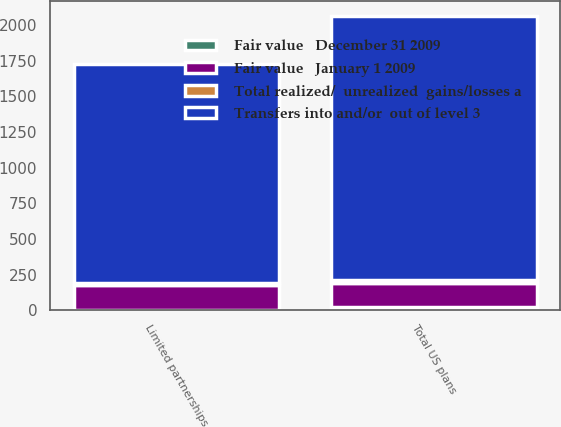Convert chart to OTSL. <chart><loc_0><loc_0><loc_500><loc_500><stacked_bar_chart><ecel><fcel>Limited partnerships<fcel>Total US plans<nl><fcel>Transfers into and/or  out of level 3<fcel>1537<fcel>1852<nl><fcel>Fair value   December 31 2009<fcel>4<fcel>23<nl><fcel>Fair value   January 1 2009<fcel>171<fcel>171<nl><fcel>Total realized/  unrealized  gains/losses a<fcel>15<fcel>15<nl></chart> 